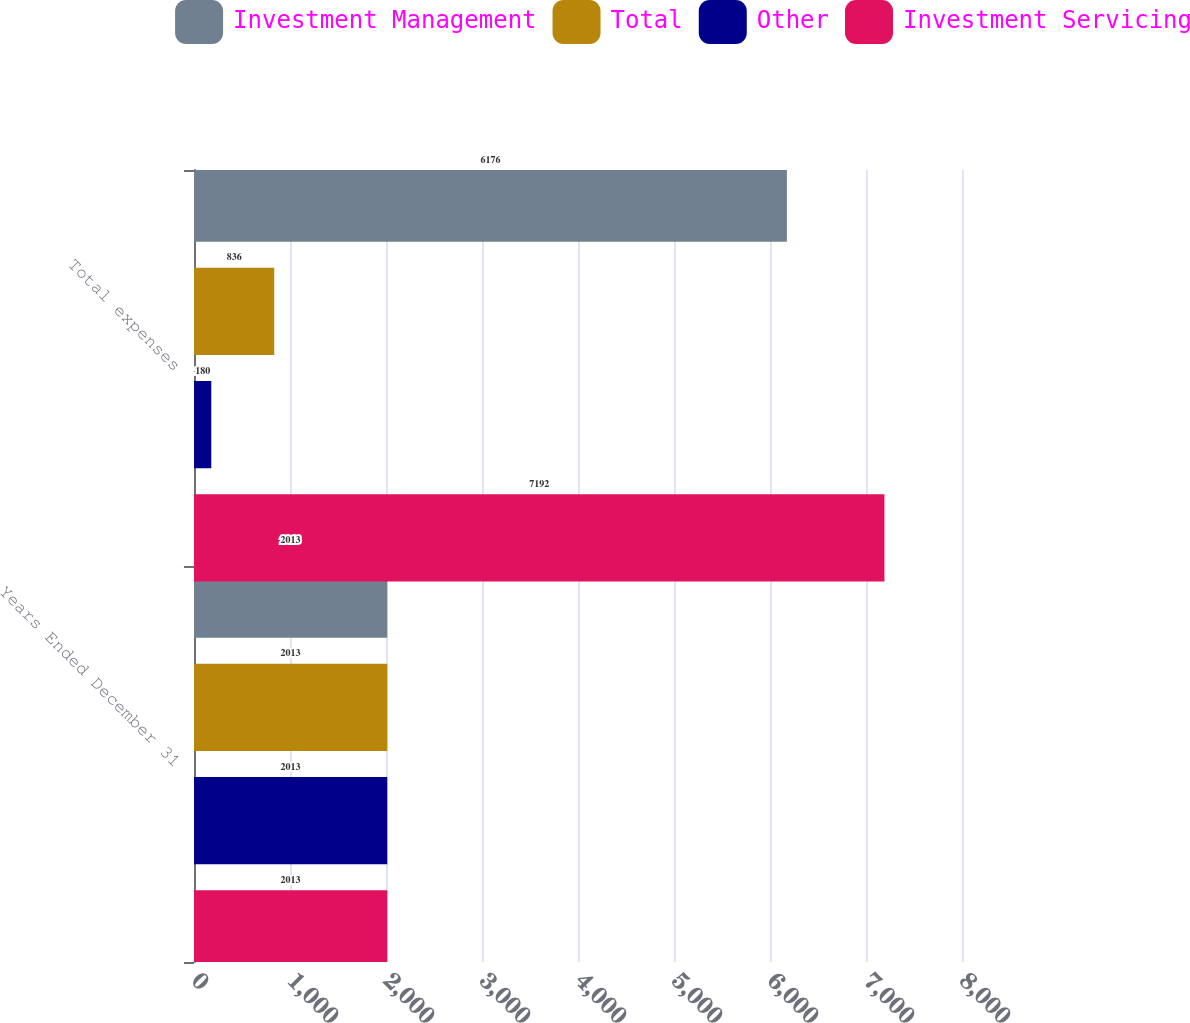<chart> <loc_0><loc_0><loc_500><loc_500><stacked_bar_chart><ecel><fcel>Years Ended December 31<fcel>Total expenses<nl><fcel>Investment Management<fcel>2013<fcel>6176<nl><fcel>Total<fcel>2013<fcel>836<nl><fcel>Other<fcel>2013<fcel>180<nl><fcel>Investment Servicing<fcel>2013<fcel>7192<nl></chart> 